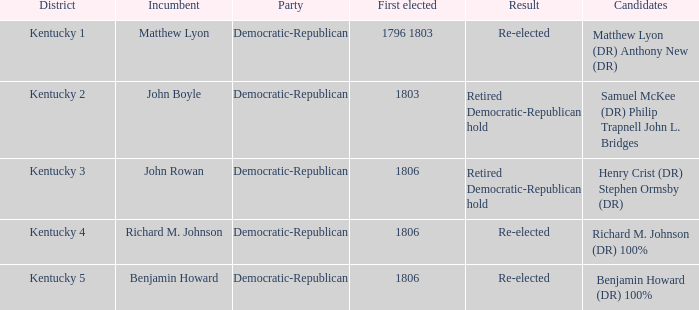Identify the initial elected representative for kentucky 1806.0. 